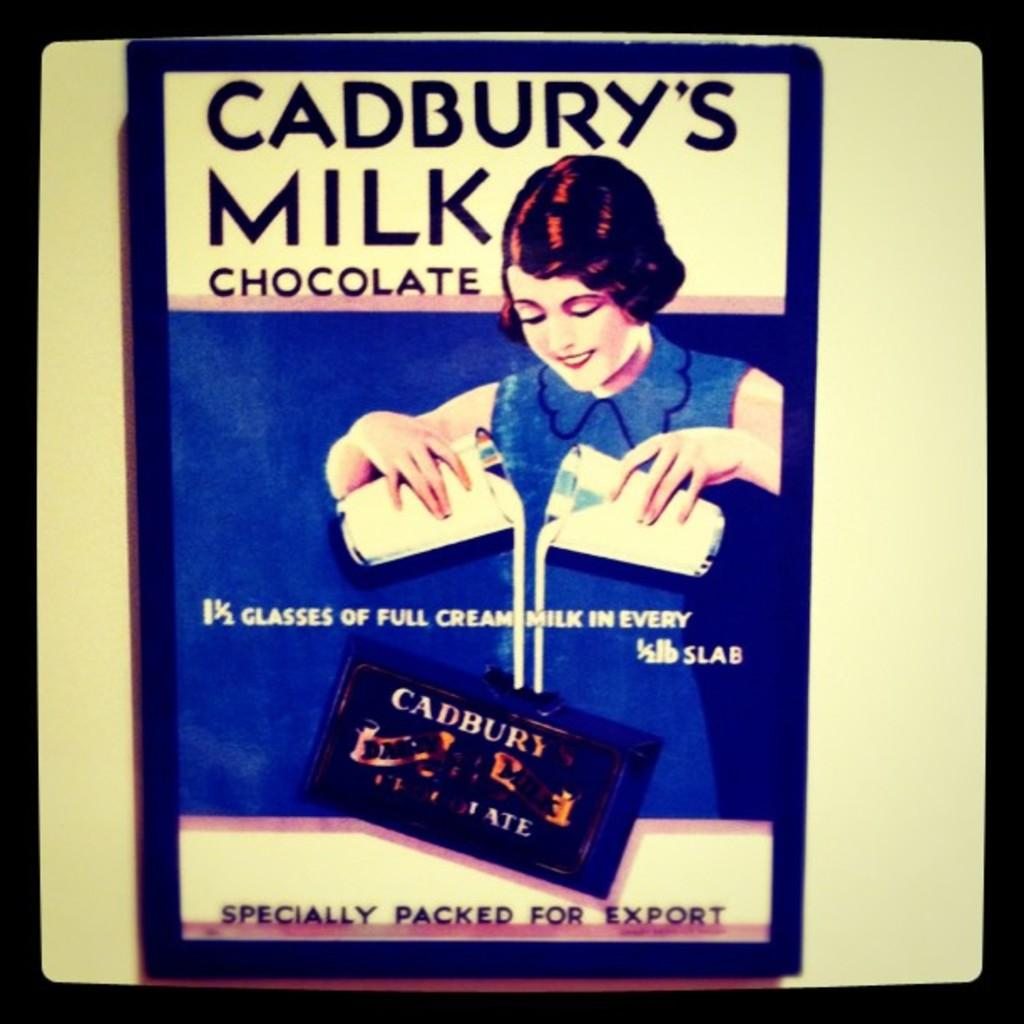<image>
Offer a succinct explanation of the picture presented. Poster that shows Cadbury's Milk Chocolate, says 1 1/2 glasses of full cream milk in every 1/2 lb slab. 